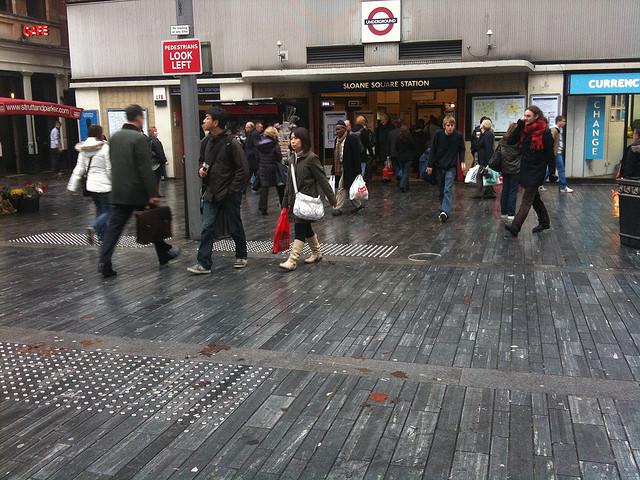Which way does the sign instruct us to look?
Give a very brief answer. Left. What type of flooring is this?
Short answer required. Wood. What color are the closest women boots?
Keep it brief. Tan. 